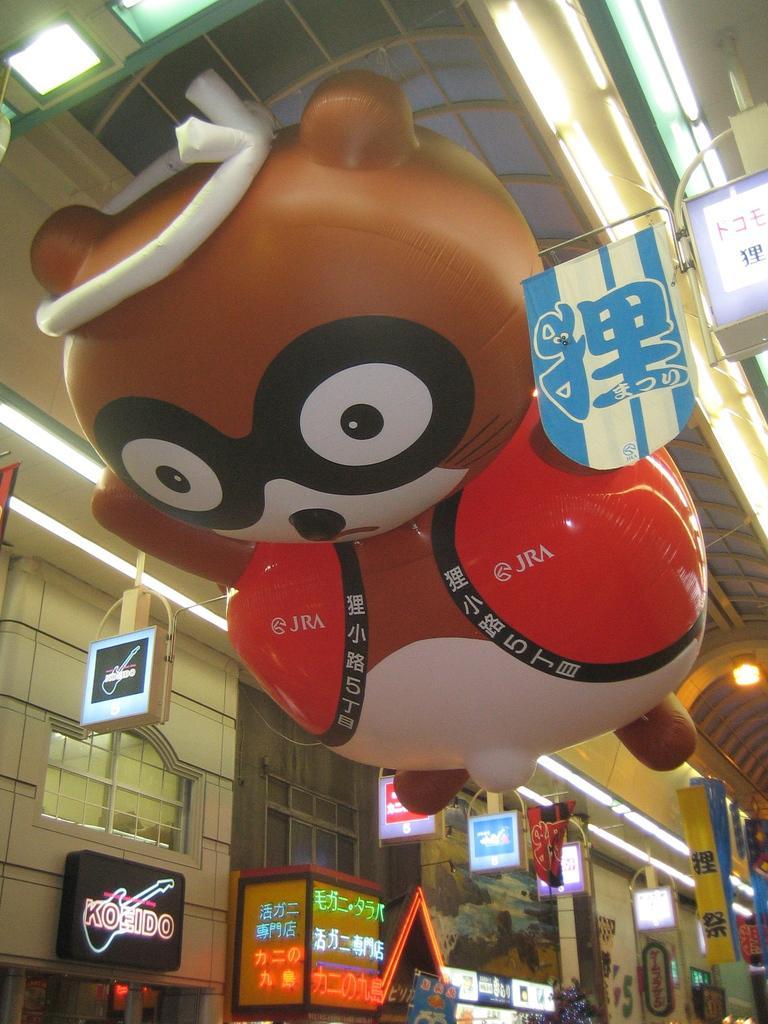Please provide a concise description of this image. In this picture we can see boards and a balloon toy, here we can see the wall, windows and some objects. 